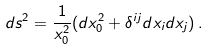Convert formula to latex. <formula><loc_0><loc_0><loc_500><loc_500>d s ^ { 2 } = \frac { 1 } { x _ { 0 } ^ { 2 } } ( d x _ { 0 } ^ { 2 } + \delta ^ { i j } d x _ { i } d x _ { j } ) \, .</formula> 